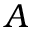<formula> <loc_0><loc_0><loc_500><loc_500>A</formula> 